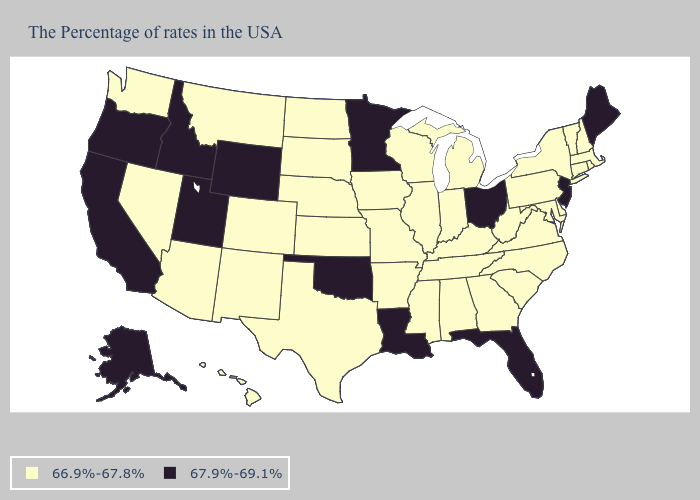Name the states that have a value in the range 66.9%-67.8%?
Give a very brief answer. Massachusetts, Rhode Island, New Hampshire, Vermont, Connecticut, New York, Delaware, Maryland, Pennsylvania, Virginia, North Carolina, South Carolina, West Virginia, Georgia, Michigan, Kentucky, Indiana, Alabama, Tennessee, Wisconsin, Illinois, Mississippi, Missouri, Arkansas, Iowa, Kansas, Nebraska, Texas, South Dakota, North Dakota, Colorado, New Mexico, Montana, Arizona, Nevada, Washington, Hawaii. Does Rhode Island have the lowest value in the Northeast?
Answer briefly. Yes. Name the states that have a value in the range 66.9%-67.8%?
Short answer required. Massachusetts, Rhode Island, New Hampshire, Vermont, Connecticut, New York, Delaware, Maryland, Pennsylvania, Virginia, North Carolina, South Carolina, West Virginia, Georgia, Michigan, Kentucky, Indiana, Alabama, Tennessee, Wisconsin, Illinois, Mississippi, Missouri, Arkansas, Iowa, Kansas, Nebraska, Texas, South Dakota, North Dakota, Colorado, New Mexico, Montana, Arizona, Nevada, Washington, Hawaii. How many symbols are there in the legend?
Write a very short answer. 2. Does Missouri have the lowest value in the MidWest?
Answer briefly. Yes. Does the first symbol in the legend represent the smallest category?
Give a very brief answer. Yes. Name the states that have a value in the range 67.9%-69.1%?
Keep it brief. Maine, New Jersey, Ohio, Florida, Louisiana, Minnesota, Oklahoma, Wyoming, Utah, Idaho, California, Oregon, Alaska. What is the lowest value in states that border Georgia?
Short answer required. 66.9%-67.8%. Does Arkansas have a higher value than Mississippi?
Write a very short answer. No. What is the lowest value in the USA?
Answer briefly. 66.9%-67.8%. Name the states that have a value in the range 67.9%-69.1%?
Concise answer only. Maine, New Jersey, Ohio, Florida, Louisiana, Minnesota, Oklahoma, Wyoming, Utah, Idaho, California, Oregon, Alaska. What is the value of Colorado?
Concise answer only. 66.9%-67.8%. What is the value of Washington?
Concise answer only. 66.9%-67.8%. Which states have the highest value in the USA?
Answer briefly. Maine, New Jersey, Ohio, Florida, Louisiana, Minnesota, Oklahoma, Wyoming, Utah, Idaho, California, Oregon, Alaska. Does Ohio have the highest value in the USA?
Keep it brief. Yes. 